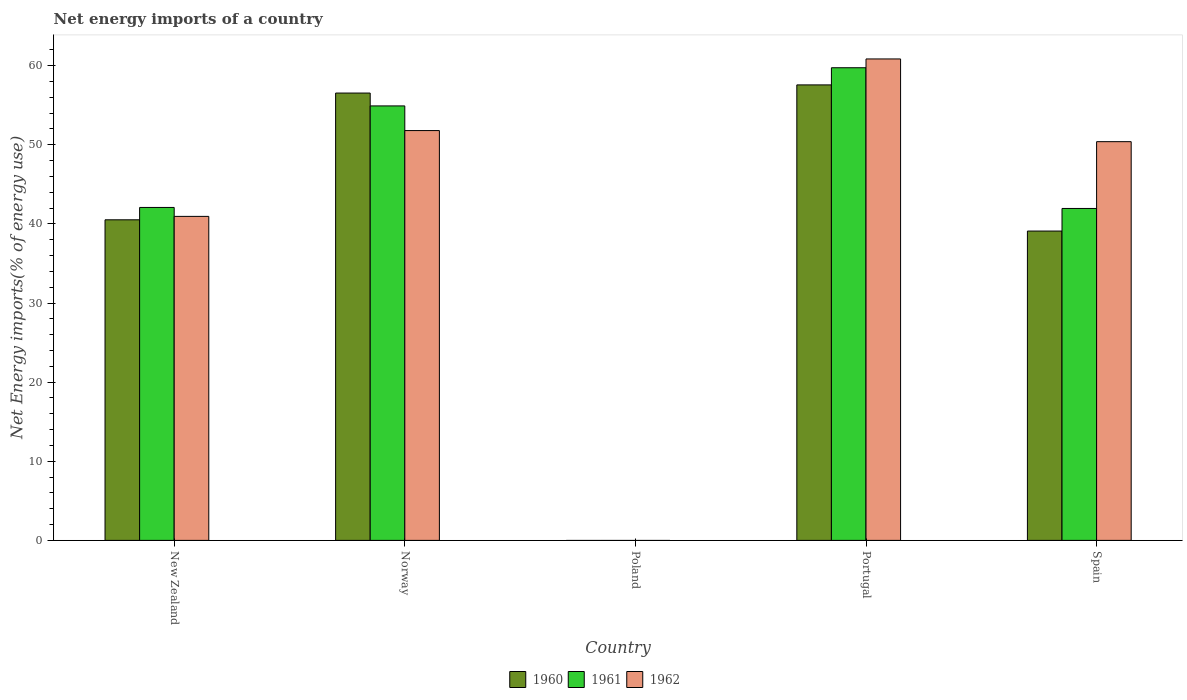How many different coloured bars are there?
Make the answer very short. 3. Are the number of bars per tick equal to the number of legend labels?
Offer a terse response. No. What is the label of the 4th group of bars from the left?
Offer a very short reply. Portugal. What is the net energy imports in 1962 in Poland?
Provide a short and direct response. 0. Across all countries, what is the maximum net energy imports in 1962?
Offer a terse response. 60.85. Across all countries, what is the minimum net energy imports in 1960?
Offer a very short reply. 0. In which country was the net energy imports in 1961 maximum?
Provide a short and direct response. Portugal. What is the total net energy imports in 1961 in the graph?
Your response must be concise. 198.7. What is the difference between the net energy imports in 1960 in Norway and that in Portugal?
Offer a very short reply. -1.03. What is the difference between the net energy imports in 1961 in Portugal and the net energy imports in 1960 in New Zealand?
Your response must be concise. 19.22. What is the average net energy imports in 1960 per country?
Keep it short and to the point. 38.75. What is the difference between the net energy imports of/in 1961 and net energy imports of/in 1960 in Norway?
Make the answer very short. -1.62. What is the ratio of the net energy imports in 1961 in Portugal to that in Spain?
Ensure brevity in your answer.  1.42. Is the net energy imports in 1960 in New Zealand less than that in Spain?
Give a very brief answer. No. What is the difference between the highest and the second highest net energy imports in 1962?
Keep it short and to the point. -1.4. What is the difference between the highest and the lowest net energy imports in 1962?
Offer a terse response. 60.85. Is the sum of the net energy imports in 1961 in Norway and Portugal greater than the maximum net energy imports in 1962 across all countries?
Provide a succinct answer. Yes. How many bars are there?
Provide a short and direct response. 12. Are all the bars in the graph horizontal?
Offer a terse response. No. Are the values on the major ticks of Y-axis written in scientific E-notation?
Offer a very short reply. No. Does the graph contain any zero values?
Your response must be concise. Yes. Does the graph contain grids?
Provide a succinct answer. No. Where does the legend appear in the graph?
Your response must be concise. Bottom center. How many legend labels are there?
Your response must be concise. 3. What is the title of the graph?
Offer a terse response. Net energy imports of a country. What is the label or title of the X-axis?
Ensure brevity in your answer.  Country. What is the label or title of the Y-axis?
Ensure brevity in your answer.  Net Energy imports(% of energy use). What is the Net Energy imports(% of energy use) of 1960 in New Zealand?
Your response must be concise. 40.52. What is the Net Energy imports(% of energy use) of 1961 in New Zealand?
Keep it short and to the point. 42.08. What is the Net Energy imports(% of energy use) in 1962 in New Zealand?
Give a very brief answer. 40.95. What is the Net Energy imports(% of energy use) in 1960 in Norway?
Offer a very short reply. 56.54. What is the Net Energy imports(% of energy use) of 1961 in Norway?
Give a very brief answer. 54.92. What is the Net Energy imports(% of energy use) in 1962 in Norway?
Offer a terse response. 51.8. What is the Net Energy imports(% of energy use) of 1961 in Poland?
Keep it short and to the point. 0. What is the Net Energy imports(% of energy use) in 1962 in Poland?
Provide a short and direct response. 0. What is the Net Energy imports(% of energy use) of 1960 in Portugal?
Provide a short and direct response. 57.57. What is the Net Energy imports(% of energy use) of 1961 in Portugal?
Keep it short and to the point. 59.74. What is the Net Energy imports(% of energy use) of 1962 in Portugal?
Your answer should be compact. 60.85. What is the Net Energy imports(% of energy use) of 1960 in Spain?
Ensure brevity in your answer.  39.1. What is the Net Energy imports(% of energy use) in 1961 in Spain?
Your answer should be compact. 41.95. What is the Net Energy imports(% of energy use) in 1962 in Spain?
Your answer should be very brief. 50.4. Across all countries, what is the maximum Net Energy imports(% of energy use) of 1960?
Provide a short and direct response. 57.57. Across all countries, what is the maximum Net Energy imports(% of energy use) of 1961?
Provide a short and direct response. 59.74. Across all countries, what is the maximum Net Energy imports(% of energy use) of 1962?
Your response must be concise. 60.85. Across all countries, what is the minimum Net Energy imports(% of energy use) in 1960?
Give a very brief answer. 0. What is the total Net Energy imports(% of energy use) of 1960 in the graph?
Make the answer very short. 193.74. What is the total Net Energy imports(% of energy use) in 1961 in the graph?
Provide a short and direct response. 198.7. What is the total Net Energy imports(% of energy use) in 1962 in the graph?
Provide a succinct answer. 204.01. What is the difference between the Net Energy imports(% of energy use) of 1960 in New Zealand and that in Norway?
Give a very brief answer. -16.02. What is the difference between the Net Energy imports(% of energy use) of 1961 in New Zealand and that in Norway?
Provide a succinct answer. -12.83. What is the difference between the Net Energy imports(% of energy use) of 1962 in New Zealand and that in Norway?
Make the answer very short. -10.85. What is the difference between the Net Energy imports(% of energy use) of 1960 in New Zealand and that in Portugal?
Offer a terse response. -17.05. What is the difference between the Net Energy imports(% of energy use) of 1961 in New Zealand and that in Portugal?
Provide a short and direct response. -17.66. What is the difference between the Net Energy imports(% of energy use) in 1962 in New Zealand and that in Portugal?
Provide a short and direct response. -19.9. What is the difference between the Net Energy imports(% of energy use) in 1960 in New Zealand and that in Spain?
Make the answer very short. 1.42. What is the difference between the Net Energy imports(% of energy use) of 1961 in New Zealand and that in Spain?
Ensure brevity in your answer.  0.13. What is the difference between the Net Energy imports(% of energy use) in 1962 in New Zealand and that in Spain?
Your response must be concise. -9.45. What is the difference between the Net Energy imports(% of energy use) in 1960 in Norway and that in Portugal?
Your answer should be compact. -1.03. What is the difference between the Net Energy imports(% of energy use) of 1961 in Norway and that in Portugal?
Make the answer very short. -4.83. What is the difference between the Net Energy imports(% of energy use) in 1962 in Norway and that in Portugal?
Offer a terse response. -9.05. What is the difference between the Net Energy imports(% of energy use) of 1960 in Norway and that in Spain?
Keep it short and to the point. 17.44. What is the difference between the Net Energy imports(% of energy use) of 1961 in Norway and that in Spain?
Offer a very short reply. 12.96. What is the difference between the Net Energy imports(% of energy use) in 1962 in Norway and that in Spain?
Give a very brief answer. 1.4. What is the difference between the Net Energy imports(% of energy use) in 1960 in Portugal and that in Spain?
Provide a short and direct response. 18.47. What is the difference between the Net Energy imports(% of energy use) of 1961 in Portugal and that in Spain?
Your response must be concise. 17.79. What is the difference between the Net Energy imports(% of energy use) in 1962 in Portugal and that in Spain?
Make the answer very short. 10.46. What is the difference between the Net Energy imports(% of energy use) of 1960 in New Zealand and the Net Energy imports(% of energy use) of 1961 in Norway?
Ensure brevity in your answer.  -14.39. What is the difference between the Net Energy imports(% of energy use) in 1960 in New Zealand and the Net Energy imports(% of energy use) in 1962 in Norway?
Make the answer very short. -11.28. What is the difference between the Net Energy imports(% of energy use) of 1961 in New Zealand and the Net Energy imports(% of energy use) of 1962 in Norway?
Offer a terse response. -9.72. What is the difference between the Net Energy imports(% of energy use) of 1960 in New Zealand and the Net Energy imports(% of energy use) of 1961 in Portugal?
Your answer should be very brief. -19.22. What is the difference between the Net Energy imports(% of energy use) in 1960 in New Zealand and the Net Energy imports(% of energy use) in 1962 in Portugal?
Keep it short and to the point. -20.33. What is the difference between the Net Energy imports(% of energy use) of 1961 in New Zealand and the Net Energy imports(% of energy use) of 1962 in Portugal?
Ensure brevity in your answer.  -18.77. What is the difference between the Net Energy imports(% of energy use) in 1960 in New Zealand and the Net Energy imports(% of energy use) in 1961 in Spain?
Offer a terse response. -1.43. What is the difference between the Net Energy imports(% of energy use) of 1960 in New Zealand and the Net Energy imports(% of energy use) of 1962 in Spain?
Keep it short and to the point. -9.88. What is the difference between the Net Energy imports(% of energy use) in 1961 in New Zealand and the Net Energy imports(% of energy use) in 1962 in Spain?
Make the answer very short. -8.32. What is the difference between the Net Energy imports(% of energy use) of 1960 in Norway and the Net Energy imports(% of energy use) of 1961 in Portugal?
Provide a succinct answer. -3.2. What is the difference between the Net Energy imports(% of energy use) of 1960 in Norway and the Net Energy imports(% of energy use) of 1962 in Portugal?
Your answer should be compact. -4.31. What is the difference between the Net Energy imports(% of energy use) of 1961 in Norway and the Net Energy imports(% of energy use) of 1962 in Portugal?
Offer a very short reply. -5.94. What is the difference between the Net Energy imports(% of energy use) in 1960 in Norway and the Net Energy imports(% of energy use) in 1961 in Spain?
Your answer should be very brief. 14.59. What is the difference between the Net Energy imports(% of energy use) of 1960 in Norway and the Net Energy imports(% of energy use) of 1962 in Spain?
Give a very brief answer. 6.14. What is the difference between the Net Energy imports(% of energy use) of 1961 in Norway and the Net Energy imports(% of energy use) of 1962 in Spain?
Your answer should be very brief. 4.52. What is the difference between the Net Energy imports(% of energy use) in 1960 in Portugal and the Net Energy imports(% of energy use) in 1961 in Spain?
Ensure brevity in your answer.  15.62. What is the difference between the Net Energy imports(% of energy use) of 1960 in Portugal and the Net Energy imports(% of energy use) of 1962 in Spain?
Your response must be concise. 7.18. What is the difference between the Net Energy imports(% of energy use) in 1961 in Portugal and the Net Energy imports(% of energy use) in 1962 in Spain?
Offer a very short reply. 9.34. What is the average Net Energy imports(% of energy use) of 1960 per country?
Offer a very short reply. 38.75. What is the average Net Energy imports(% of energy use) of 1961 per country?
Ensure brevity in your answer.  39.74. What is the average Net Energy imports(% of energy use) of 1962 per country?
Make the answer very short. 40.8. What is the difference between the Net Energy imports(% of energy use) of 1960 and Net Energy imports(% of energy use) of 1961 in New Zealand?
Your response must be concise. -1.56. What is the difference between the Net Energy imports(% of energy use) of 1960 and Net Energy imports(% of energy use) of 1962 in New Zealand?
Give a very brief answer. -0.43. What is the difference between the Net Energy imports(% of energy use) of 1961 and Net Energy imports(% of energy use) of 1962 in New Zealand?
Offer a terse response. 1.13. What is the difference between the Net Energy imports(% of energy use) in 1960 and Net Energy imports(% of energy use) in 1961 in Norway?
Your answer should be compact. 1.62. What is the difference between the Net Energy imports(% of energy use) of 1960 and Net Energy imports(% of energy use) of 1962 in Norway?
Your response must be concise. 4.74. What is the difference between the Net Energy imports(% of energy use) of 1961 and Net Energy imports(% of energy use) of 1962 in Norway?
Offer a very short reply. 3.12. What is the difference between the Net Energy imports(% of energy use) of 1960 and Net Energy imports(% of energy use) of 1961 in Portugal?
Ensure brevity in your answer.  -2.17. What is the difference between the Net Energy imports(% of energy use) in 1960 and Net Energy imports(% of energy use) in 1962 in Portugal?
Offer a terse response. -3.28. What is the difference between the Net Energy imports(% of energy use) in 1961 and Net Energy imports(% of energy use) in 1962 in Portugal?
Your answer should be compact. -1.11. What is the difference between the Net Energy imports(% of energy use) of 1960 and Net Energy imports(% of energy use) of 1961 in Spain?
Ensure brevity in your answer.  -2.85. What is the difference between the Net Energy imports(% of energy use) of 1960 and Net Energy imports(% of energy use) of 1962 in Spain?
Your answer should be very brief. -11.3. What is the difference between the Net Energy imports(% of energy use) in 1961 and Net Energy imports(% of energy use) in 1962 in Spain?
Give a very brief answer. -8.44. What is the ratio of the Net Energy imports(% of energy use) of 1960 in New Zealand to that in Norway?
Your answer should be compact. 0.72. What is the ratio of the Net Energy imports(% of energy use) in 1961 in New Zealand to that in Norway?
Ensure brevity in your answer.  0.77. What is the ratio of the Net Energy imports(% of energy use) in 1962 in New Zealand to that in Norway?
Keep it short and to the point. 0.79. What is the ratio of the Net Energy imports(% of energy use) of 1960 in New Zealand to that in Portugal?
Your answer should be very brief. 0.7. What is the ratio of the Net Energy imports(% of energy use) of 1961 in New Zealand to that in Portugal?
Keep it short and to the point. 0.7. What is the ratio of the Net Energy imports(% of energy use) in 1962 in New Zealand to that in Portugal?
Offer a terse response. 0.67. What is the ratio of the Net Energy imports(% of energy use) in 1960 in New Zealand to that in Spain?
Ensure brevity in your answer.  1.04. What is the ratio of the Net Energy imports(% of energy use) in 1961 in New Zealand to that in Spain?
Your response must be concise. 1. What is the ratio of the Net Energy imports(% of energy use) in 1962 in New Zealand to that in Spain?
Keep it short and to the point. 0.81. What is the ratio of the Net Energy imports(% of energy use) of 1960 in Norway to that in Portugal?
Keep it short and to the point. 0.98. What is the ratio of the Net Energy imports(% of energy use) in 1961 in Norway to that in Portugal?
Your answer should be compact. 0.92. What is the ratio of the Net Energy imports(% of energy use) in 1962 in Norway to that in Portugal?
Keep it short and to the point. 0.85. What is the ratio of the Net Energy imports(% of energy use) of 1960 in Norway to that in Spain?
Make the answer very short. 1.45. What is the ratio of the Net Energy imports(% of energy use) of 1961 in Norway to that in Spain?
Your answer should be compact. 1.31. What is the ratio of the Net Energy imports(% of energy use) of 1962 in Norway to that in Spain?
Provide a succinct answer. 1.03. What is the ratio of the Net Energy imports(% of energy use) in 1960 in Portugal to that in Spain?
Offer a very short reply. 1.47. What is the ratio of the Net Energy imports(% of energy use) of 1961 in Portugal to that in Spain?
Give a very brief answer. 1.42. What is the ratio of the Net Energy imports(% of energy use) of 1962 in Portugal to that in Spain?
Provide a short and direct response. 1.21. What is the difference between the highest and the second highest Net Energy imports(% of energy use) in 1960?
Provide a succinct answer. 1.03. What is the difference between the highest and the second highest Net Energy imports(% of energy use) of 1961?
Your response must be concise. 4.83. What is the difference between the highest and the second highest Net Energy imports(% of energy use) of 1962?
Make the answer very short. 9.05. What is the difference between the highest and the lowest Net Energy imports(% of energy use) of 1960?
Provide a succinct answer. 57.57. What is the difference between the highest and the lowest Net Energy imports(% of energy use) of 1961?
Make the answer very short. 59.74. What is the difference between the highest and the lowest Net Energy imports(% of energy use) of 1962?
Provide a short and direct response. 60.85. 